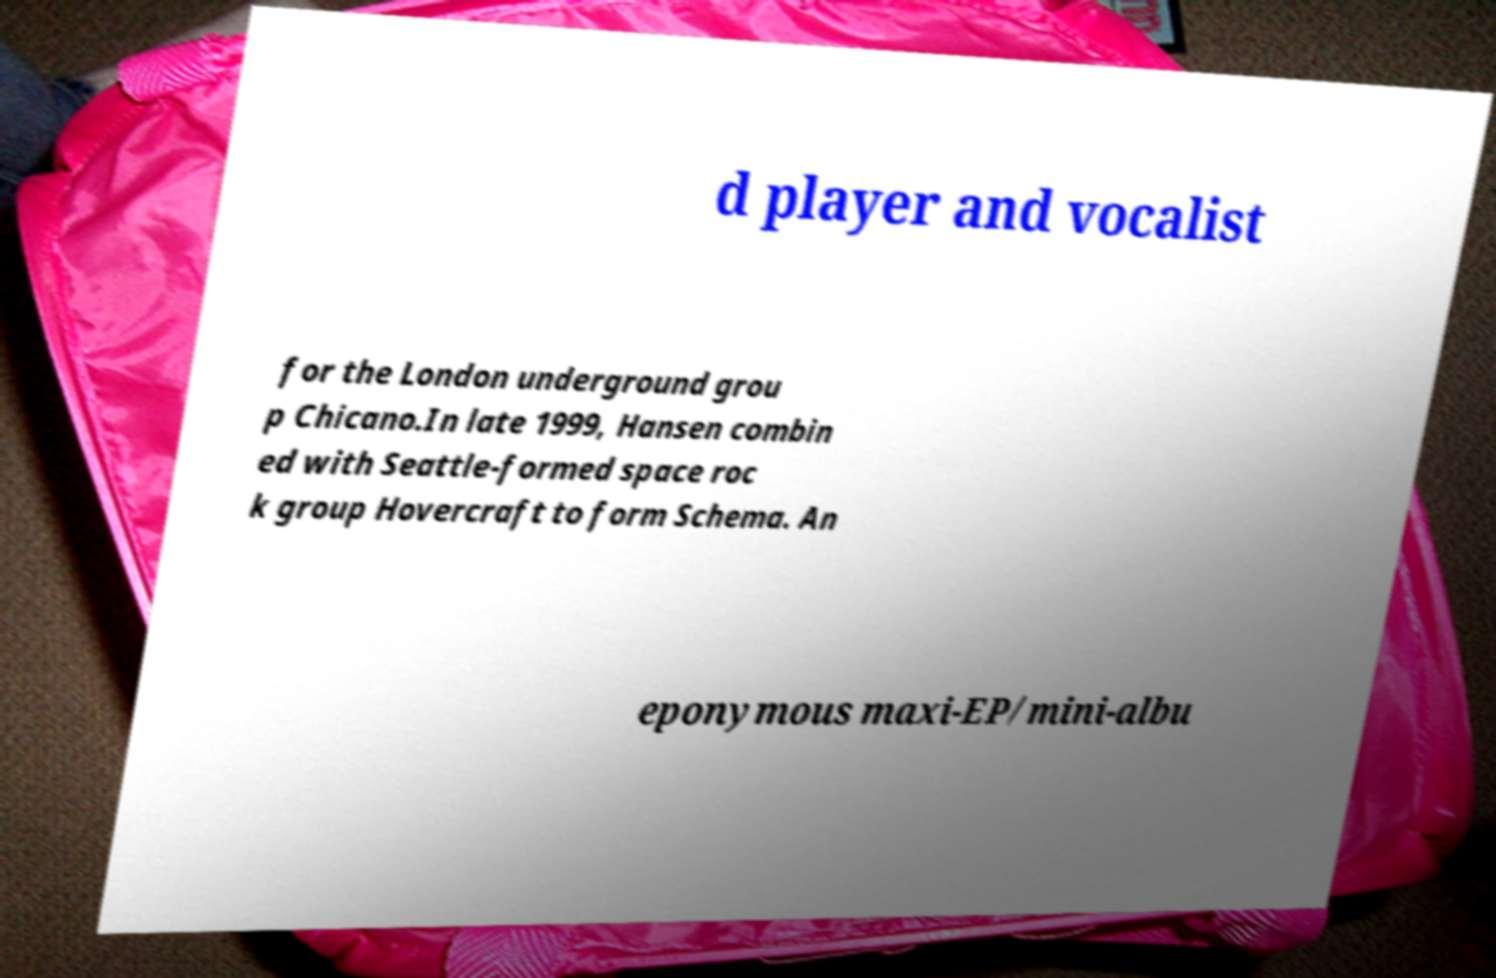Please read and relay the text visible in this image. What does it say? d player and vocalist for the London underground grou p Chicano.In late 1999, Hansen combin ed with Seattle-formed space roc k group Hovercraft to form Schema. An eponymous maxi-EP/mini-albu 